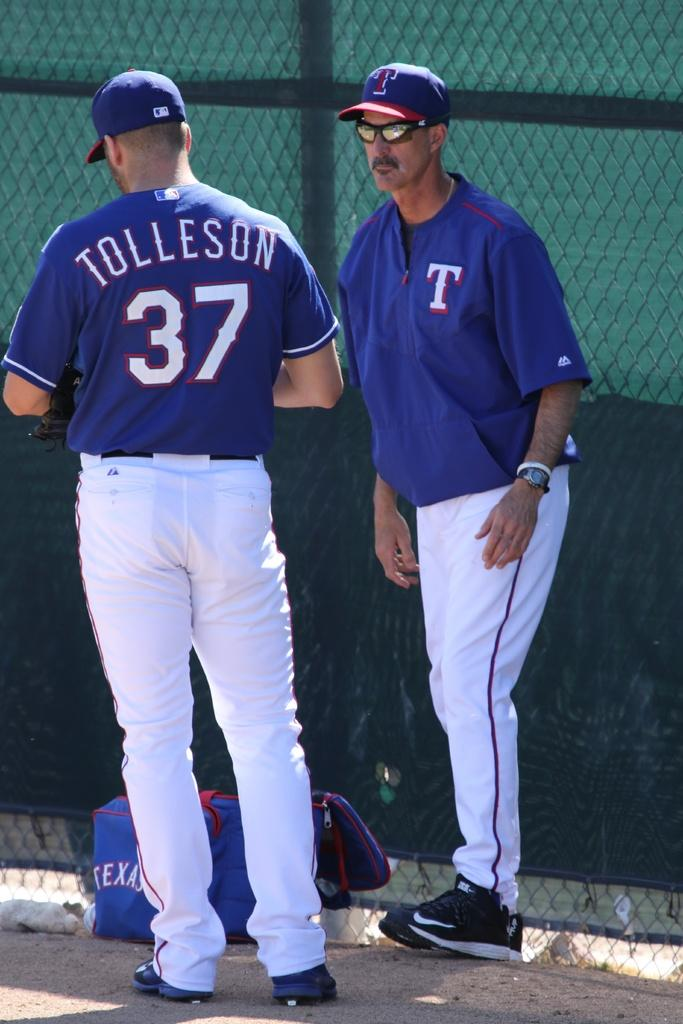Provide a one-sentence caption for the provided image. A man wearing a blue and white unifom with Tolleson displayed on his back. 